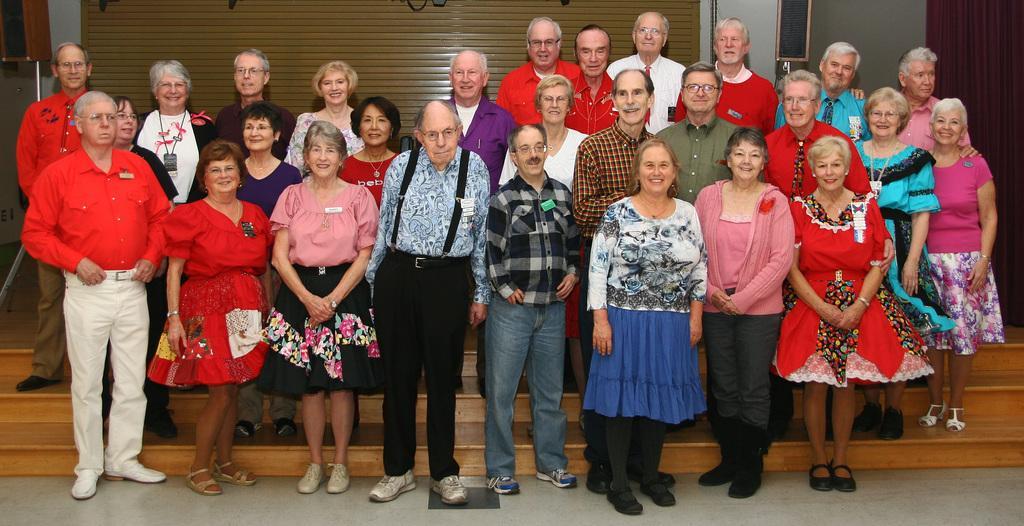Could you give a brief overview of what you see in this image? In the picture we can see an old man and few old women are standing near the steps and some of them are smiling and behind them we can see a wall with a shutter. 